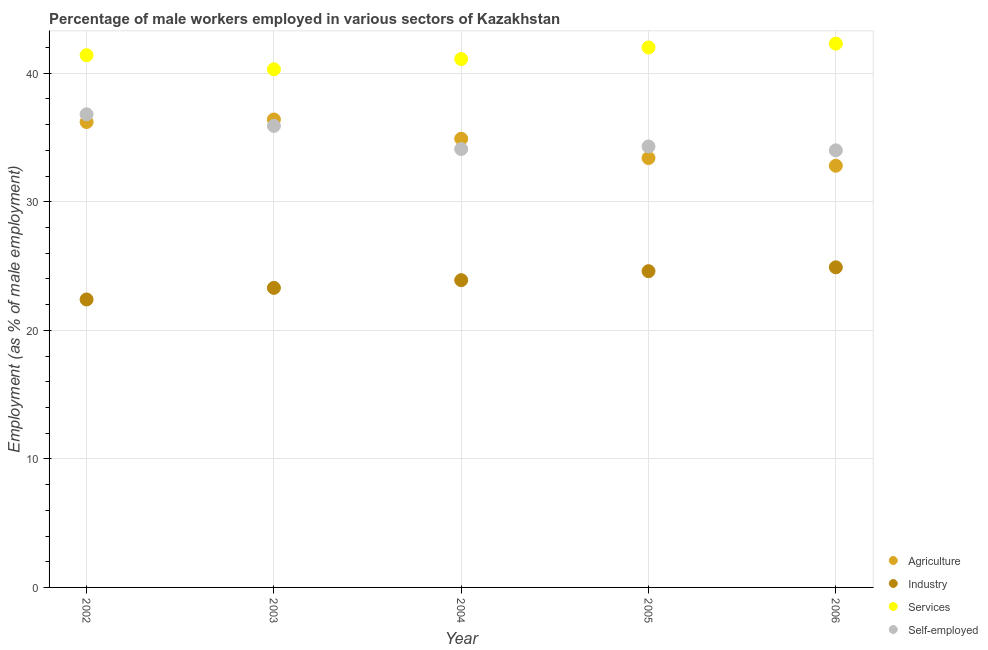How many different coloured dotlines are there?
Offer a very short reply. 4. Is the number of dotlines equal to the number of legend labels?
Offer a terse response. Yes. What is the percentage of male workers in agriculture in 2003?
Keep it short and to the point. 36.4. Across all years, what is the maximum percentage of male workers in industry?
Give a very brief answer. 24.9. Across all years, what is the minimum percentage of male workers in services?
Keep it short and to the point. 40.3. What is the total percentage of male workers in services in the graph?
Your answer should be very brief. 207.1. What is the difference between the percentage of male workers in agriculture in 2004 and that in 2006?
Give a very brief answer. 2.1. What is the difference between the percentage of male workers in industry in 2006 and the percentage of self employed male workers in 2002?
Keep it short and to the point. -11.9. What is the average percentage of male workers in agriculture per year?
Ensure brevity in your answer.  34.74. In the year 2006, what is the difference between the percentage of male workers in services and percentage of male workers in industry?
Keep it short and to the point. 17.4. In how many years, is the percentage of male workers in agriculture greater than 26 %?
Offer a terse response. 5. What is the ratio of the percentage of male workers in services in 2004 to that in 2006?
Offer a terse response. 0.97. What is the difference between the highest and the second highest percentage of male workers in services?
Provide a succinct answer. 0.3. What is the difference between the highest and the lowest percentage of self employed male workers?
Provide a succinct answer. 2.8. In how many years, is the percentage of male workers in services greater than the average percentage of male workers in services taken over all years?
Your answer should be very brief. 2. Is it the case that in every year, the sum of the percentage of self employed male workers and percentage of male workers in industry is greater than the sum of percentage of male workers in agriculture and percentage of male workers in services?
Your answer should be very brief. No. Is it the case that in every year, the sum of the percentage of male workers in agriculture and percentage of male workers in industry is greater than the percentage of male workers in services?
Make the answer very short. Yes. Does the percentage of self employed male workers monotonically increase over the years?
Offer a very short reply. No. Is the percentage of male workers in agriculture strictly greater than the percentage of self employed male workers over the years?
Your answer should be very brief. No. Is the percentage of male workers in industry strictly less than the percentage of male workers in services over the years?
Your answer should be compact. Yes. How many dotlines are there?
Offer a very short reply. 4. Are the values on the major ticks of Y-axis written in scientific E-notation?
Provide a succinct answer. No. Does the graph contain any zero values?
Ensure brevity in your answer.  No. Does the graph contain grids?
Provide a short and direct response. Yes. How many legend labels are there?
Your response must be concise. 4. What is the title of the graph?
Provide a short and direct response. Percentage of male workers employed in various sectors of Kazakhstan. Does "Bird species" appear as one of the legend labels in the graph?
Your answer should be very brief. No. What is the label or title of the Y-axis?
Your answer should be compact. Employment (as % of male employment). What is the Employment (as % of male employment) of Agriculture in 2002?
Provide a succinct answer. 36.2. What is the Employment (as % of male employment) in Industry in 2002?
Ensure brevity in your answer.  22.4. What is the Employment (as % of male employment) of Services in 2002?
Your response must be concise. 41.4. What is the Employment (as % of male employment) of Self-employed in 2002?
Offer a very short reply. 36.8. What is the Employment (as % of male employment) of Agriculture in 2003?
Your answer should be compact. 36.4. What is the Employment (as % of male employment) in Industry in 2003?
Your answer should be very brief. 23.3. What is the Employment (as % of male employment) in Services in 2003?
Give a very brief answer. 40.3. What is the Employment (as % of male employment) in Self-employed in 2003?
Your response must be concise. 35.9. What is the Employment (as % of male employment) of Agriculture in 2004?
Provide a short and direct response. 34.9. What is the Employment (as % of male employment) in Industry in 2004?
Make the answer very short. 23.9. What is the Employment (as % of male employment) of Services in 2004?
Your response must be concise. 41.1. What is the Employment (as % of male employment) in Self-employed in 2004?
Your answer should be very brief. 34.1. What is the Employment (as % of male employment) in Agriculture in 2005?
Offer a terse response. 33.4. What is the Employment (as % of male employment) of Industry in 2005?
Make the answer very short. 24.6. What is the Employment (as % of male employment) in Self-employed in 2005?
Provide a short and direct response. 34.3. What is the Employment (as % of male employment) of Agriculture in 2006?
Give a very brief answer. 32.8. What is the Employment (as % of male employment) in Industry in 2006?
Your answer should be compact. 24.9. What is the Employment (as % of male employment) of Services in 2006?
Your response must be concise. 42.3. Across all years, what is the maximum Employment (as % of male employment) of Agriculture?
Your response must be concise. 36.4. Across all years, what is the maximum Employment (as % of male employment) of Industry?
Offer a very short reply. 24.9. Across all years, what is the maximum Employment (as % of male employment) of Services?
Ensure brevity in your answer.  42.3. Across all years, what is the maximum Employment (as % of male employment) in Self-employed?
Keep it short and to the point. 36.8. Across all years, what is the minimum Employment (as % of male employment) in Agriculture?
Keep it short and to the point. 32.8. Across all years, what is the minimum Employment (as % of male employment) in Industry?
Your response must be concise. 22.4. Across all years, what is the minimum Employment (as % of male employment) in Services?
Ensure brevity in your answer.  40.3. What is the total Employment (as % of male employment) in Agriculture in the graph?
Your response must be concise. 173.7. What is the total Employment (as % of male employment) of Industry in the graph?
Your answer should be very brief. 119.1. What is the total Employment (as % of male employment) in Services in the graph?
Provide a succinct answer. 207.1. What is the total Employment (as % of male employment) of Self-employed in the graph?
Give a very brief answer. 175.1. What is the difference between the Employment (as % of male employment) of Industry in 2002 and that in 2003?
Keep it short and to the point. -0.9. What is the difference between the Employment (as % of male employment) in Industry in 2002 and that in 2004?
Offer a very short reply. -1.5. What is the difference between the Employment (as % of male employment) of Self-employed in 2002 and that in 2004?
Your response must be concise. 2.7. What is the difference between the Employment (as % of male employment) of Industry in 2003 and that in 2004?
Provide a short and direct response. -0.6. What is the difference between the Employment (as % of male employment) in Self-employed in 2003 and that in 2004?
Your answer should be very brief. 1.8. What is the difference between the Employment (as % of male employment) in Industry in 2003 and that in 2005?
Offer a terse response. -1.3. What is the difference between the Employment (as % of male employment) in Services in 2003 and that in 2005?
Offer a very short reply. -1.7. What is the difference between the Employment (as % of male employment) of Self-employed in 2003 and that in 2005?
Keep it short and to the point. 1.6. What is the difference between the Employment (as % of male employment) in Agriculture in 2003 and that in 2006?
Keep it short and to the point. 3.6. What is the difference between the Employment (as % of male employment) in Self-employed in 2003 and that in 2006?
Keep it short and to the point. 1.9. What is the difference between the Employment (as % of male employment) in Agriculture in 2004 and that in 2006?
Make the answer very short. 2.1. What is the difference between the Employment (as % of male employment) of Industry in 2004 and that in 2006?
Keep it short and to the point. -1. What is the difference between the Employment (as % of male employment) of Services in 2004 and that in 2006?
Keep it short and to the point. -1.2. What is the difference between the Employment (as % of male employment) in Self-employed in 2005 and that in 2006?
Provide a succinct answer. 0.3. What is the difference between the Employment (as % of male employment) of Agriculture in 2002 and the Employment (as % of male employment) of Services in 2003?
Offer a very short reply. -4.1. What is the difference between the Employment (as % of male employment) in Agriculture in 2002 and the Employment (as % of male employment) in Self-employed in 2003?
Provide a short and direct response. 0.3. What is the difference between the Employment (as % of male employment) in Industry in 2002 and the Employment (as % of male employment) in Services in 2003?
Offer a terse response. -17.9. What is the difference between the Employment (as % of male employment) of Industry in 2002 and the Employment (as % of male employment) of Self-employed in 2003?
Offer a very short reply. -13.5. What is the difference between the Employment (as % of male employment) in Industry in 2002 and the Employment (as % of male employment) in Services in 2004?
Ensure brevity in your answer.  -18.7. What is the difference between the Employment (as % of male employment) in Industry in 2002 and the Employment (as % of male employment) in Self-employed in 2004?
Your answer should be compact. -11.7. What is the difference between the Employment (as % of male employment) of Services in 2002 and the Employment (as % of male employment) of Self-employed in 2004?
Your response must be concise. 7.3. What is the difference between the Employment (as % of male employment) in Agriculture in 2002 and the Employment (as % of male employment) in Industry in 2005?
Give a very brief answer. 11.6. What is the difference between the Employment (as % of male employment) in Agriculture in 2002 and the Employment (as % of male employment) in Self-employed in 2005?
Keep it short and to the point. 1.9. What is the difference between the Employment (as % of male employment) in Industry in 2002 and the Employment (as % of male employment) in Services in 2005?
Your response must be concise. -19.6. What is the difference between the Employment (as % of male employment) of Industry in 2002 and the Employment (as % of male employment) of Self-employed in 2005?
Offer a very short reply. -11.9. What is the difference between the Employment (as % of male employment) of Agriculture in 2002 and the Employment (as % of male employment) of Industry in 2006?
Ensure brevity in your answer.  11.3. What is the difference between the Employment (as % of male employment) of Agriculture in 2002 and the Employment (as % of male employment) of Services in 2006?
Keep it short and to the point. -6.1. What is the difference between the Employment (as % of male employment) of Agriculture in 2002 and the Employment (as % of male employment) of Self-employed in 2006?
Provide a succinct answer. 2.2. What is the difference between the Employment (as % of male employment) in Industry in 2002 and the Employment (as % of male employment) in Services in 2006?
Make the answer very short. -19.9. What is the difference between the Employment (as % of male employment) of Services in 2002 and the Employment (as % of male employment) of Self-employed in 2006?
Keep it short and to the point. 7.4. What is the difference between the Employment (as % of male employment) of Agriculture in 2003 and the Employment (as % of male employment) of Services in 2004?
Your answer should be very brief. -4.7. What is the difference between the Employment (as % of male employment) in Agriculture in 2003 and the Employment (as % of male employment) in Self-employed in 2004?
Ensure brevity in your answer.  2.3. What is the difference between the Employment (as % of male employment) in Industry in 2003 and the Employment (as % of male employment) in Services in 2004?
Your answer should be compact. -17.8. What is the difference between the Employment (as % of male employment) in Services in 2003 and the Employment (as % of male employment) in Self-employed in 2004?
Your answer should be compact. 6.2. What is the difference between the Employment (as % of male employment) of Industry in 2003 and the Employment (as % of male employment) of Services in 2005?
Ensure brevity in your answer.  -18.7. What is the difference between the Employment (as % of male employment) in Industry in 2003 and the Employment (as % of male employment) in Self-employed in 2005?
Make the answer very short. -11. What is the difference between the Employment (as % of male employment) in Services in 2003 and the Employment (as % of male employment) in Self-employed in 2005?
Offer a terse response. 6. What is the difference between the Employment (as % of male employment) of Agriculture in 2003 and the Employment (as % of male employment) of Services in 2006?
Give a very brief answer. -5.9. What is the difference between the Employment (as % of male employment) of Industry in 2003 and the Employment (as % of male employment) of Services in 2006?
Offer a terse response. -19. What is the difference between the Employment (as % of male employment) of Industry in 2003 and the Employment (as % of male employment) of Self-employed in 2006?
Keep it short and to the point. -10.7. What is the difference between the Employment (as % of male employment) of Agriculture in 2004 and the Employment (as % of male employment) of Industry in 2005?
Make the answer very short. 10.3. What is the difference between the Employment (as % of male employment) in Agriculture in 2004 and the Employment (as % of male employment) in Self-employed in 2005?
Your answer should be very brief. 0.6. What is the difference between the Employment (as % of male employment) in Industry in 2004 and the Employment (as % of male employment) in Services in 2005?
Your answer should be very brief. -18.1. What is the difference between the Employment (as % of male employment) in Services in 2004 and the Employment (as % of male employment) in Self-employed in 2005?
Ensure brevity in your answer.  6.8. What is the difference between the Employment (as % of male employment) of Agriculture in 2004 and the Employment (as % of male employment) of Services in 2006?
Offer a very short reply. -7.4. What is the difference between the Employment (as % of male employment) in Agriculture in 2004 and the Employment (as % of male employment) in Self-employed in 2006?
Your answer should be compact. 0.9. What is the difference between the Employment (as % of male employment) of Industry in 2004 and the Employment (as % of male employment) of Services in 2006?
Your answer should be very brief. -18.4. What is the difference between the Employment (as % of male employment) of Services in 2004 and the Employment (as % of male employment) of Self-employed in 2006?
Your response must be concise. 7.1. What is the difference between the Employment (as % of male employment) in Agriculture in 2005 and the Employment (as % of male employment) in Self-employed in 2006?
Provide a succinct answer. -0.6. What is the difference between the Employment (as % of male employment) in Industry in 2005 and the Employment (as % of male employment) in Services in 2006?
Keep it short and to the point. -17.7. What is the difference between the Employment (as % of male employment) in Industry in 2005 and the Employment (as % of male employment) in Self-employed in 2006?
Give a very brief answer. -9.4. What is the difference between the Employment (as % of male employment) in Services in 2005 and the Employment (as % of male employment) in Self-employed in 2006?
Provide a succinct answer. 8. What is the average Employment (as % of male employment) in Agriculture per year?
Your answer should be compact. 34.74. What is the average Employment (as % of male employment) of Industry per year?
Provide a short and direct response. 23.82. What is the average Employment (as % of male employment) in Services per year?
Your response must be concise. 41.42. What is the average Employment (as % of male employment) of Self-employed per year?
Offer a terse response. 35.02. In the year 2002, what is the difference between the Employment (as % of male employment) in Agriculture and Employment (as % of male employment) in Services?
Give a very brief answer. -5.2. In the year 2002, what is the difference between the Employment (as % of male employment) of Industry and Employment (as % of male employment) of Services?
Give a very brief answer. -19. In the year 2002, what is the difference between the Employment (as % of male employment) in Industry and Employment (as % of male employment) in Self-employed?
Your response must be concise. -14.4. In the year 2002, what is the difference between the Employment (as % of male employment) of Services and Employment (as % of male employment) of Self-employed?
Keep it short and to the point. 4.6. In the year 2003, what is the difference between the Employment (as % of male employment) in Agriculture and Employment (as % of male employment) in Industry?
Make the answer very short. 13.1. In the year 2003, what is the difference between the Employment (as % of male employment) in Agriculture and Employment (as % of male employment) in Services?
Offer a very short reply. -3.9. In the year 2003, what is the difference between the Employment (as % of male employment) in Agriculture and Employment (as % of male employment) in Self-employed?
Give a very brief answer. 0.5. In the year 2003, what is the difference between the Employment (as % of male employment) in Industry and Employment (as % of male employment) in Services?
Offer a terse response. -17. In the year 2004, what is the difference between the Employment (as % of male employment) in Agriculture and Employment (as % of male employment) in Industry?
Make the answer very short. 11. In the year 2004, what is the difference between the Employment (as % of male employment) in Agriculture and Employment (as % of male employment) in Services?
Make the answer very short. -6.2. In the year 2004, what is the difference between the Employment (as % of male employment) in Agriculture and Employment (as % of male employment) in Self-employed?
Your answer should be compact. 0.8. In the year 2004, what is the difference between the Employment (as % of male employment) of Industry and Employment (as % of male employment) of Services?
Offer a terse response. -17.2. In the year 2004, what is the difference between the Employment (as % of male employment) in Industry and Employment (as % of male employment) in Self-employed?
Give a very brief answer. -10.2. In the year 2004, what is the difference between the Employment (as % of male employment) in Services and Employment (as % of male employment) in Self-employed?
Offer a terse response. 7. In the year 2005, what is the difference between the Employment (as % of male employment) of Agriculture and Employment (as % of male employment) of Self-employed?
Ensure brevity in your answer.  -0.9. In the year 2005, what is the difference between the Employment (as % of male employment) in Industry and Employment (as % of male employment) in Services?
Give a very brief answer. -17.4. In the year 2005, what is the difference between the Employment (as % of male employment) in Industry and Employment (as % of male employment) in Self-employed?
Your response must be concise. -9.7. In the year 2005, what is the difference between the Employment (as % of male employment) of Services and Employment (as % of male employment) of Self-employed?
Provide a succinct answer. 7.7. In the year 2006, what is the difference between the Employment (as % of male employment) in Agriculture and Employment (as % of male employment) in Services?
Ensure brevity in your answer.  -9.5. In the year 2006, what is the difference between the Employment (as % of male employment) in Agriculture and Employment (as % of male employment) in Self-employed?
Your answer should be compact. -1.2. In the year 2006, what is the difference between the Employment (as % of male employment) in Industry and Employment (as % of male employment) in Services?
Make the answer very short. -17.4. In the year 2006, what is the difference between the Employment (as % of male employment) of Industry and Employment (as % of male employment) of Self-employed?
Provide a short and direct response. -9.1. In the year 2006, what is the difference between the Employment (as % of male employment) of Services and Employment (as % of male employment) of Self-employed?
Your answer should be compact. 8.3. What is the ratio of the Employment (as % of male employment) in Industry in 2002 to that in 2003?
Your answer should be very brief. 0.96. What is the ratio of the Employment (as % of male employment) of Services in 2002 to that in 2003?
Ensure brevity in your answer.  1.03. What is the ratio of the Employment (as % of male employment) of Self-employed in 2002 to that in 2003?
Keep it short and to the point. 1.03. What is the ratio of the Employment (as % of male employment) of Agriculture in 2002 to that in 2004?
Offer a very short reply. 1.04. What is the ratio of the Employment (as % of male employment) in Industry in 2002 to that in 2004?
Your answer should be very brief. 0.94. What is the ratio of the Employment (as % of male employment) in Services in 2002 to that in 2004?
Your answer should be compact. 1.01. What is the ratio of the Employment (as % of male employment) in Self-employed in 2002 to that in 2004?
Your answer should be very brief. 1.08. What is the ratio of the Employment (as % of male employment) of Agriculture in 2002 to that in 2005?
Offer a terse response. 1.08. What is the ratio of the Employment (as % of male employment) in Industry in 2002 to that in 2005?
Offer a terse response. 0.91. What is the ratio of the Employment (as % of male employment) of Services in 2002 to that in 2005?
Offer a terse response. 0.99. What is the ratio of the Employment (as % of male employment) in Self-employed in 2002 to that in 2005?
Your answer should be very brief. 1.07. What is the ratio of the Employment (as % of male employment) in Agriculture in 2002 to that in 2006?
Give a very brief answer. 1.1. What is the ratio of the Employment (as % of male employment) in Industry in 2002 to that in 2006?
Your answer should be very brief. 0.9. What is the ratio of the Employment (as % of male employment) of Services in 2002 to that in 2006?
Provide a short and direct response. 0.98. What is the ratio of the Employment (as % of male employment) of Self-employed in 2002 to that in 2006?
Offer a terse response. 1.08. What is the ratio of the Employment (as % of male employment) of Agriculture in 2003 to that in 2004?
Keep it short and to the point. 1.04. What is the ratio of the Employment (as % of male employment) in Industry in 2003 to that in 2004?
Your answer should be very brief. 0.97. What is the ratio of the Employment (as % of male employment) of Services in 2003 to that in 2004?
Your response must be concise. 0.98. What is the ratio of the Employment (as % of male employment) in Self-employed in 2003 to that in 2004?
Provide a succinct answer. 1.05. What is the ratio of the Employment (as % of male employment) of Agriculture in 2003 to that in 2005?
Your response must be concise. 1.09. What is the ratio of the Employment (as % of male employment) in Industry in 2003 to that in 2005?
Your answer should be very brief. 0.95. What is the ratio of the Employment (as % of male employment) of Services in 2003 to that in 2005?
Offer a very short reply. 0.96. What is the ratio of the Employment (as % of male employment) of Self-employed in 2003 to that in 2005?
Offer a very short reply. 1.05. What is the ratio of the Employment (as % of male employment) of Agriculture in 2003 to that in 2006?
Your answer should be very brief. 1.11. What is the ratio of the Employment (as % of male employment) of Industry in 2003 to that in 2006?
Your answer should be very brief. 0.94. What is the ratio of the Employment (as % of male employment) in Services in 2003 to that in 2006?
Provide a short and direct response. 0.95. What is the ratio of the Employment (as % of male employment) in Self-employed in 2003 to that in 2006?
Give a very brief answer. 1.06. What is the ratio of the Employment (as % of male employment) of Agriculture in 2004 to that in 2005?
Offer a terse response. 1.04. What is the ratio of the Employment (as % of male employment) in Industry in 2004 to that in 2005?
Provide a short and direct response. 0.97. What is the ratio of the Employment (as % of male employment) in Services in 2004 to that in 2005?
Offer a very short reply. 0.98. What is the ratio of the Employment (as % of male employment) in Self-employed in 2004 to that in 2005?
Offer a very short reply. 0.99. What is the ratio of the Employment (as % of male employment) in Agriculture in 2004 to that in 2006?
Ensure brevity in your answer.  1.06. What is the ratio of the Employment (as % of male employment) in Industry in 2004 to that in 2006?
Give a very brief answer. 0.96. What is the ratio of the Employment (as % of male employment) of Services in 2004 to that in 2006?
Your response must be concise. 0.97. What is the ratio of the Employment (as % of male employment) of Self-employed in 2004 to that in 2006?
Your answer should be very brief. 1. What is the ratio of the Employment (as % of male employment) in Agriculture in 2005 to that in 2006?
Your answer should be compact. 1.02. What is the ratio of the Employment (as % of male employment) in Industry in 2005 to that in 2006?
Keep it short and to the point. 0.99. What is the ratio of the Employment (as % of male employment) in Services in 2005 to that in 2006?
Provide a short and direct response. 0.99. What is the ratio of the Employment (as % of male employment) of Self-employed in 2005 to that in 2006?
Make the answer very short. 1.01. What is the difference between the highest and the second highest Employment (as % of male employment) of Industry?
Provide a succinct answer. 0.3. What is the difference between the highest and the second highest Employment (as % of male employment) in Services?
Your response must be concise. 0.3. What is the difference between the highest and the second highest Employment (as % of male employment) in Self-employed?
Ensure brevity in your answer.  0.9. What is the difference between the highest and the lowest Employment (as % of male employment) in Agriculture?
Provide a succinct answer. 3.6. What is the difference between the highest and the lowest Employment (as % of male employment) of Industry?
Offer a very short reply. 2.5. What is the difference between the highest and the lowest Employment (as % of male employment) in Services?
Keep it short and to the point. 2. What is the difference between the highest and the lowest Employment (as % of male employment) in Self-employed?
Offer a terse response. 2.8. 